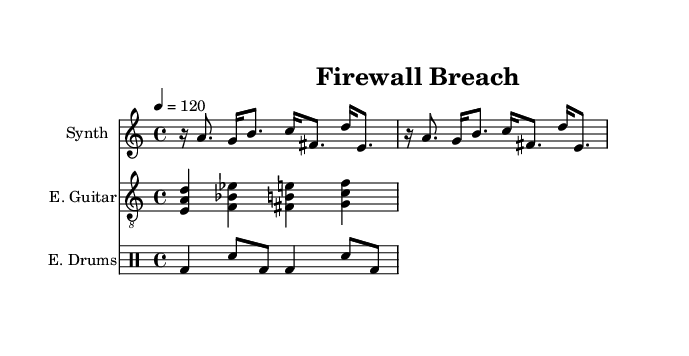What is the time signature of this music? The time signature is indicated at the beginning of the score, which shows a 4/4 time signature, meaning there are four beats per measure.
Answer: 4/4 What is the tempo marking of this piece? The tempo marking, which sets the pace for the music, is found at the beginning and is indicated as 4 = 120, meaning there are 120 beats per minute.
Answer: 120 How many measures are there in the synth melody? By analyzing the synth melody section of the score, I can count the total number of measures played, which is 2 in this case.
Answer: 2 What is the clef used for the guitar part? The guitar part notation specifies a treble clef, which is indicated in the score above the guitar staff.
Answer: treble How many different instruments are indicated in this score? Upon reviewing the score, there are three distinct instruments presented: Synth, E. Guitar, and E. Drums, each represented on its own staff.
Answer: three What type of music is represented in this score? The title "Firewall Breach" and the characteristics of the score, including industrial noise influences, characterize this piece as Experimental music.
Answer: Experimental 